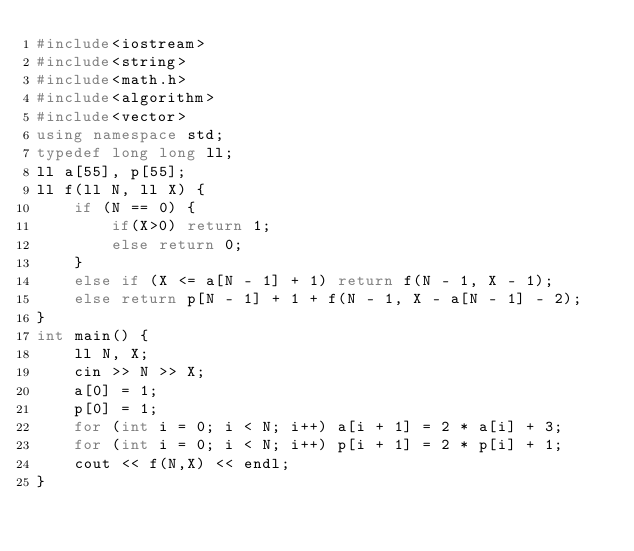Convert code to text. <code><loc_0><loc_0><loc_500><loc_500><_C++_>#include<iostream>
#include<string>
#include<math.h>
#include<algorithm>
#include<vector>
using namespace std;
typedef long long ll;
ll a[55], p[55];
ll f(ll N, ll X) {
	if (N == 0) {
		if(X>0) return 1;
		else return 0;
	}
	else if (X <= a[N - 1] + 1) return f(N - 1, X - 1);
	else return p[N - 1] + 1 + f(N - 1, X - a[N - 1] - 2);
}
int main() {
	ll N, X;
	cin >> N >> X;
	a[0] = 1;
	p[0] = 1;
	for (int i = 0; i < N; i++) a[i + 1] = 2 * a[i] + 3;
	for (int i = 0; i < N; i++) p[i + 1] = 2 * p[i] + 1;
	cout << f(N,X) << endl;
}</code> 